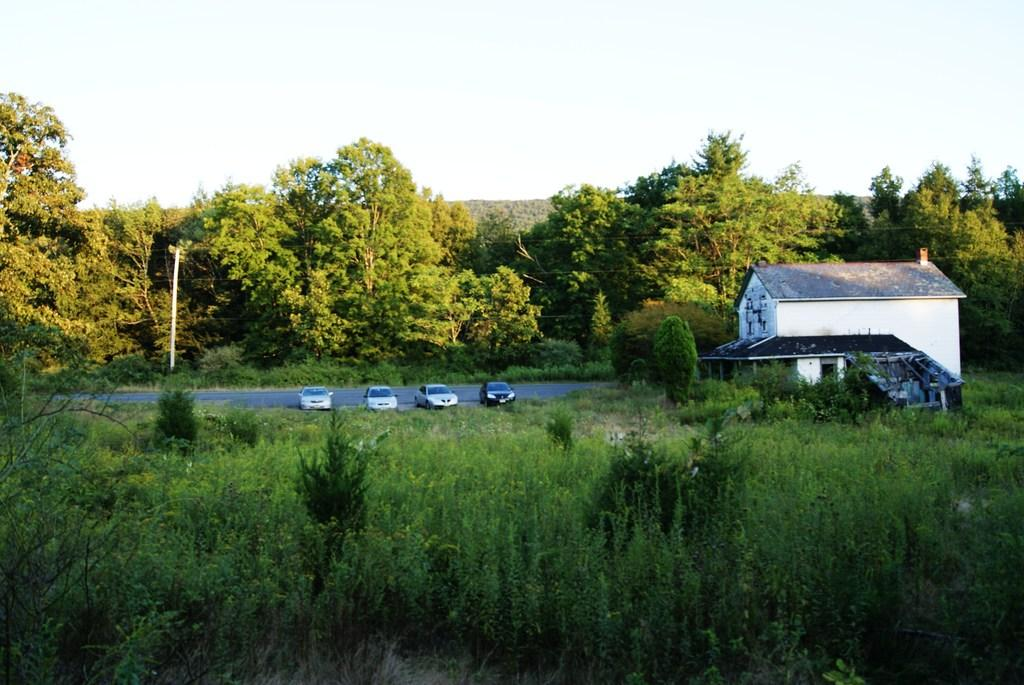What type of vehicles can be seen in the image? There are cars in the image. What is the primary surface that the cars are on? There is a road in the image. What type of natural elements are present in the image? There are trees in the image. What type of structure can be seen in the image? There is a pole in the image. What type of buildings are visible in the image? There are houses in the image. What is visible at the top of the image? The sky is visible at the top of the image. Can you tell me how many writers are visible in the image? There are no writers present in the image. What type of spacecraft can be seen in the image? There is no spacecraft present in the image. 